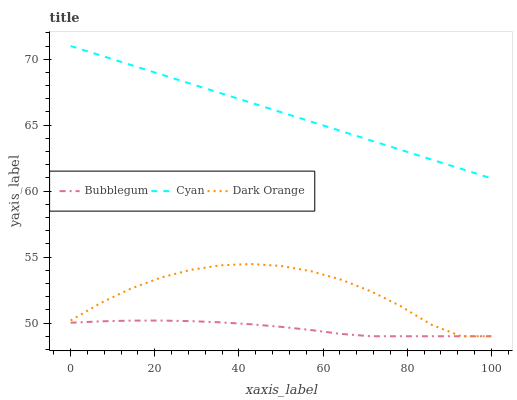Does Bubblegum have the minimum area under the curve?
Answer yes or no. Yes. Does Cyan have the maximum area under the curve?
Answer yes or no. Yes. Does Dark Orange have the minimum area under the curve?
Answer yes or no. No. Does Dark Orange have the maximum area under the curve?
Answer yes or no. No. Is Cyan the smoothest?
Answer yes or no. Yes. Is Dark Orange the roughest?
Answer yes or no. Yes. Is Bubblegum the smoothest?
Answer yes or no. No. Is Bubblegum the roughest?
Answer yes or no. No. Does Bubblegum have the lowest value?
Answer yes or no. Yes. Does Cyan have the highest value?
Answer yes or no. Yes. Does Dark Orange have the highest value?
Answer yes or no. No. Is Bubblegum less than Cyan?
Answer yes or no. Yes. Is Cyan greater than Dark Orange?
Answer yes or no. Yes. Does Dark Orange intersect Bubblegum?
Answer yes or no. Yes. Is Dark Orange less than Bubblegum?
Answer yes or no. No. Is Dark Orange greater than Bubblegum?
Answer yes or no. No. Does Bubblegum intersect Cyan?
Answer yes or no. No. 